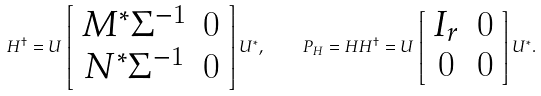Convert formula to latex. <formula><loc_0><loc_0><loc_500><loc_500>H ^ { \dag } = U \left [ \begin{array} { c c } M ^ { * } \Sigma ^ { - 1 } & 0 \\ N ^ { * } \Sigma ^ { - 1 } & 0 \\ \end{array} \right ] U ^ { * } , \quad P _ { H } = H H ^ { \dag } = U \left [ \begin{array} { c c } I _ { r } & 0 \\ 0 & 0 \\ \end{array} \right ] U ^ { * } .</formula> 